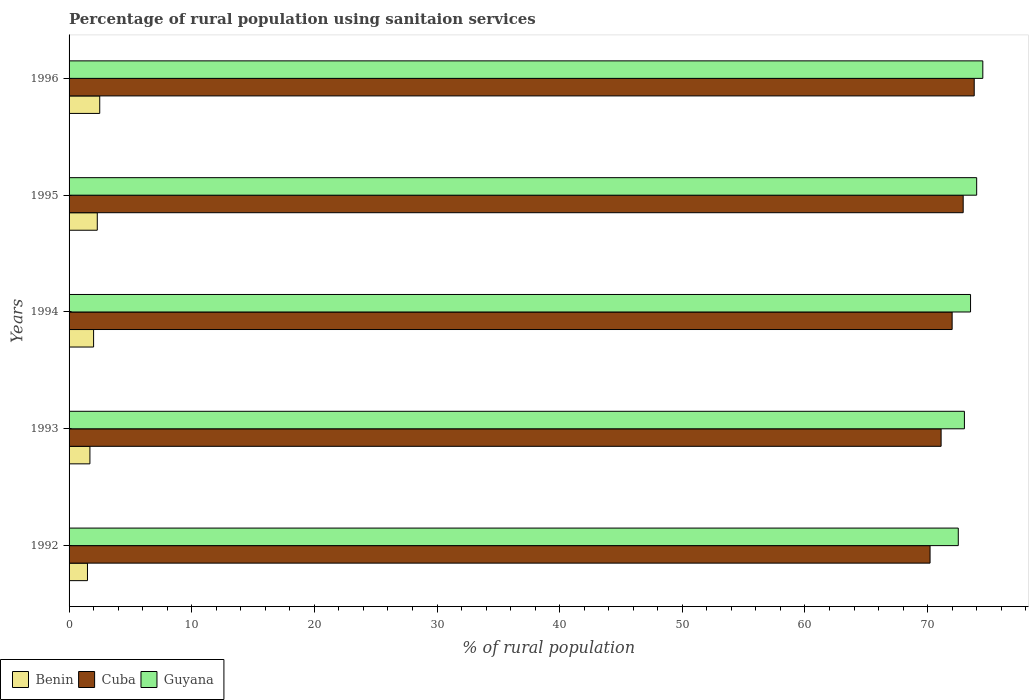How many different coloured bars are there?
Your answer should be compact. 3. How many groups of bars are there?
Provide a short and direct response. 5. Are the number of bars on each tick of the Y-axis equal?
Keep it short and to the point. Yes. In how many cases, is the number of bars for a given year not equal to the number of legend labels?
Ensure brevity in your answer.  0. Across all years, what is the minimum percentage of rural population using sanitaion services in Benin?
Make the answer very short. 1.5. What is the total percentage of rural population using sanitaion services in Cuba in the graph?
Make the answer very short. 360. What is the difference between the percentage of rural population using sanitaion services in Benin in 1994 and that in 1995?
Provide a succinct answer. -0.3. What is the difference between the percentage of rural population using sanitaion services in Benin in 1993 and the percentage of rural population using sanitaion services in Cuba in 1996?
Provide a short and direct response. -72.1. What is the average percentage of rural population using sanitaion services in Cuba per year?
Your answer should be compact. 72. In the year 1992, what is the difference between the percentage of rural population using sanitaion services in Cuba and percentage of rural population using sanitaion services in Guyana?
Ensure brevity in your answer.  -2.3. What is the ratio of the percentage of rural population using sanitaion services in Benin in 1994 to that in 1996?
Your answer should be compact. 0.8. Is the percentage of rural population using sanitaion services in Guyana in 1992 less than that in 1995?
Provide a succinct answer. Yes. What is the difference between the highest and the second highest percentage of rural population using sanitaion services in Guyana?
Provide a short and direct response. 0.5. What is the difference between the highest and the lowest percentage of rural population using sanitaion services in Benin?
Provide a succinct answer. 1. In how many years, is the percentage of rural population using sanitaion services in Benin greater than the average percentage of rural population using sanitaion services in Benin taken over all years?
Offer a terse response. 2. Is the sum of the percentage of rural population using sanitaion services in Cuba in 1993 and 1994 greater than the maximum percentage of rural population using sanitaion services in Benin across all years?
Make the answer very short. Yes. What does the 2nd bar from the top in 1993 represents?
Provide a short and direct response. Cuba. What does the 1st bar from the bottom in 1994 represents?
Make the answer very short. Benin. How many bars are there?
Your answer should be very brief. 15. Are all the bars in the graph horizontal?
Make the answer very short. Yes. Are the values on the major ticks of X-axis written in scientific E-notation?
Offer a terse response. No. Where does the legend appear in the graph?
Provide a short and direct response. Bottom left. What is the title of the graph?
Your answer should be compact. Percentage of rural population using sanitaion services. What is the label or title of the X-axis?
Provide a short and direct response. % of rural population. What is the label or title of the Y-axis?
Your answer should be very brief. Years. What is the % of rural population of Benin in 1992?
Provide a short and direct response. 1.5. What is the % of rural population in Cuba in 1992?
Your response must be concise. 70.2. What is the % of rural population of Guyana in 1992?
Provide a succinct answer. 72.5. What is the % of rural population of Benin in 1993?
Your answer should be very brief. 1.7. What is the % of rural population of Cuba in 1993?
Give a very brief answer. 71.1. What is the % of rural population of Guyana in 1993?
Give a very brief answer. 73. What is the % of rural population in Cuba in 1994?
Offer a terse response. 72. What is the % of rural population of Guyana in 1994?
Your answer should be compact. 73.5. What is the % of rural population of Cuba in 1995?
Provide a succinct answer. 72.9. What is the % of rural population of Guyana in 1995?
Give a very brief answer. 74. What is the % of rural population of Benin in 1996?
Offer a very short reply. 2.5. What is the % of rural population of Cuba in 1996?
Offer a terse response. 73.8. What is the % of rural population in Guyana in 1996?
Offer a very short reply. 74.5. Across all years, what is the maximum % of rural population of Benin?
Provide a short and direct response. 2.5. Across all years, what is the maximum % of rural population of Cuba?
Make the answer very short. 73.8. Across all years, what is the maximum % of rural population in Guyana?
Your answer should be very brief. 74.5. Across all years, what is the minimum % of rural population of Benin?
Make the answer very short. 1.5. Across all years, what is the minimum % of rural population of Cuba?
Ensure brevity in your answer.  70.2. Across all years, what is the minimum % of rural population in Guyana?
Offer a terse response. 72.5. What is the total % of rural population in Benin in the graph?
Your answer should be compact. 10. What is the total % of rural population of Cuba in the graph?
Your answer should be compact. 360. What is the total % of rural population in Guyana in the graph?
Offer a very short reply. 367.5. What is the difference between the % of rural population of Guyana in 1992 and that in 1993?
Offer a very short reply. -0.5. What is the difference between the % of rural population of Guyana in 1992 and that in 1994?
Your answer should be compact. -1. What is the difference between the % of rural population in Benin in 1992 and that in 1995?
Your answer should be compact. -0.8. What is the difference between the % of rural population of Guyana in 1992 and that in 1995?
Keep it short and to the point. -1.5. What is the difference between the % of rural population in Guyana in 1992 and that in 1996?
Your answer should be very brief. -2. What is the difference between the % of rural population in Cuba in 1993 and that in 1994?
Ensure brevity in your answer.  -0.9. What is the difference between the % of rural population of Guyana in 1993 and that in 1994?
Keep it short and to the point. -0.5. What is the difference between the % of rural population in Benin in 1993 and that in 1996?
Give a very brief answer. -0.8. What is the difference between the % of rural population in Cuba in 1993 and that in 1996?
Provide a succinct answer. -2.7. What is the difference between the % of rural population in Benin in 1994 and that in 1995?
Keep it short and to the point. -0.3. What is the difference between the % of rural population in Guyana in 1994 and that in 1995?
Make the answer very short. -0.5. What is the difference between the % of rural population in Benin in 1995 and that in 1996?
Keep it short and to the point. -0.2. What is the difference between the % of rural population in Benin in 1992 and the % of rural population in Cuba in 1993?
Provide a short and direct response. -69.6. What is the difference between the % of rural population of Benin in 1992 and the % of rural population of Guyana in 1993?
Your answer should be compact. -71.5. What is the difference between the % of rural population of Cuba in 1992 and the % of rural population of Guyana in 1993?
Offer a terse response. -2.8. What is the difference between the % of rural population in Benin in 1992 and the % of rural population in Cuba in 1994?
Offer a terse response. -70.5. What is the difference between the % of rural population of Benin in 1992 and the % of rural population of Guyana in 1994?
Provide a short and direct response. -72. What is the difference between the % of rural population of Cuba in 1992 and the % of rural population of Guyana in 1994?
Ensure brevity in your answer.  -3.3. What is the difference between the % of rural population of Benin in 1992 and the % of rural population of Cuba in 1995?
Ensure brevity in your answer.  -71.4. What is the difference between the % of rural population in Benin in 1992 and the % of rural population in Guyana in 1995?
Give a very brief answer. -72.5. What is the difference between the % of rural population of Cuba in 1992 and the % of rural population of Guyana in 1995?
Offer a very short reply. -3.8. What is the difference between the % of rural population in Benin in 1992 and the % of rural population in Cuba in 1996?
Ensure brevity in your answer.  -72.3. What is the difference between the % of rural population in Benin in 1992 and the % of rural population in Guyana in 1996?
Provide a succinct answer. -73. What is the difference between the % of rural population of Cuba in 1992 and the % of rural population of Guyana in 1996?
Your answer should be very brief. -4.3. What is the difference between the % of rural population in Benin in 1993 and the % of rural population in Cuba in 1994?
Your answer should be compact. -70.3. What is the difference between the % of rural population of Benin in 1993 and the % of rural population of Guyana in 1994?
Keep it short and to the point. -71.8. What is the difference between the % of rural population in Benin in 1993 and the % of rural population in Cuba in 1995?
Make the answer very short. -71.2. What is the difference between the % of rural population in Benin in 1993 and the % of rural population in Guyana in 1995?
Provide a succinct answer. -72.3. What is the difference between the % of rural population in Benin in 1993 and the % of rural population in Cuba in 1996?
Provide a succinct answer. -72.1. What is the difference between the % of rural population of Benin in 1993 and the % of rural population of Guyana in 1996?
Provide a short and direct response. -72.8. What is the difference between the % of rural population in Benin in 1994 and the % of rural population in Cuba in 1995?
Keep it short and to the point. -70.9. What is the difference between the % of rural population in Benin in 1994 and the % of rural population in Guyana in 1995?
Make the answer very short. -72. What is the difference between the % of rural population of Cuba in 1994 and the % of rural population of Guyana in 1995?
Your answer should be very brief. -2. What is the difference between the % of rural population in Benin in 1994 and the % of rural population in Cuba in 1996?
Your answer should be compact. -71.8. What is the difference between the % of rural population in Benin in 1994 and the % of rural population in Guyana in 1996?
Ensure brevity in your answer.  -72.5. What is the difference between the % of rural population in Benin in 1995 and the % of rural population in Cuba in 1996?
Your response must be concise. -71.5. What is the difference between the % of rural population of Benin in 1995 and the % of rural population of Guyana in 1996?
Your response must be concise. -72.2. What is the difference between the % of rural population in Cuba in 1995 and the % of rural population in Guyana in 1996?
Keep it short and to the point. -1.6. What is the average % of rural population of Cuba per year?
Provide a succinct answer. 72. What is the average % of rural population in Guyana per year?
Give a very brief answer. 73.5. In the year 1992, what is the difference between the % of rural population of Benin and % of rural population of Cuba?
Provide a succinct answer. -68.7. In the year 1992, what is the difference between the % of rural population in Benin and % of rural population in Guyana?
Give a very brief answer. -71. In the year 1992, what is the difference between the % of rural population of Cuba and % of rural population of Guyana?
Provide a short and direct response. -2.3. In the year 1993, what is the difference between the % of rural population in Benin and % of rural population in Cuba?
Your answer should be very brief. -69.4. In the year 1993, what is the difference between the % of rural population of Benin and % of rural population of Guyana?
Offer a terse response. -71.3. In the year 1994, what is the difference between the % of rural population of Benin and % of rural population of Cuba?
Keep it short and to the point. -70. In the year 1994, what is the difference between the % of rural population of Benin and % of rural population of Guyana?
Your answer should be very brief. -71.5. In the year 1995, what is the difference between the % of rural population of Benin and % of rural population of Cuba?
Provide a short and direct response. -70.6. In the year 1995, what is the difference between the % of rural population in Benin and % of rural population in Guyana?
Offer a very short reply. -71.7. In the year 1996, what is the difference between the % of rural population in Benin and % of rural population in Cuba?
Provide a succinct answer. -71.3. In the year 1996, what is the difference between the % of rural population in Benin and % of rural population in Guyana?
Your answer should be compact. -72. What is the ratio of the % of rural population of Benin in 1992 to that in 1993?
Your response must be concise. 0.88. What is the ratio of the % of rural population of Cuba in 1992 to that in 1993?
Ensure brevity in your answer.  0.99. What is the ratio of the % of rural population in Benin in 1992 to that in 1994?
Offer a very short reply. 0.75. What is the ratio of the % of rural population in Cuba in 1992 to that in 1994?
Your response must be concise. 0.97. What is the ratio of the % of rural population of Guyana in 1992 to that in 1994?
Ensure brevity in your answer.  0.99. What is the ratio of the % of rural population of Benin in 1992 to that in 1995?
Your response must be concise. 0.65. What is the ratio of the % of rural population in Cuba in 1992 to that in 1995?
Ensure brevity in your answer.  0.96. What is the ratio of the % of rural population of Guyana in 1992 to that in 1995?
Your response must be concise. 0.98. What is the ratio of the % of rural population in Benin in 1992 to that in 1996?
Your response must be concise. 0.6. What is the ratio of the % of rural population of Cuba in 1992 to that in 1996?
Offer a terse response. 0.95. What is the ratio of the % of rural population in Guyana in 1992 to that in 1996?
Make the answer very short. 0.97. What is the ratio of the % of rural population of Cuba in 1993 to that in 1994?
Provide a short and direct response. 0.99. What is the ratio of the % of rural population in Guyana in 1993 to that in 1994?
Your answer should be very brief. 0.99. What is the ratio of the % of rural population of Benin in 1993 to that in 1995?
Your answer should be very brief. 0.74. What is the ratio of the % of rural population of Cuba in 1993 to that in 1995?
Offer a terse response. 0.98. What is the ratio of the % of rural population in Guyana in 1993 to that in 1995?
Ensure brevity in your answer.  0.99. What is the ratio of the % of rural population of Benin in 1993 to that in 1996?
Keep it short and to the point. 0.68. What is the ratio of the % of rural population of Cuba in 1993 to that in 1996?
Your answer should be very brief. 0.96. What is the ratio of the % of rural population of Guyana in 1993 to that in 1996?
Ensure brevity in your answer.  0.98. What is the ratio of the % of rural population of Benin in 1994 to that in 1995?
Keep it short and to the point. 0.87. What is the ratio of the % of rural population in Benin in 1994 to that in 1996?
Offer a very short reply. 0.8. What is the ratio of the % of rural population of Cuba in 1994 to that in 1996?
Give a very brief answer. 0.98. What is the ratio of the % of rural population in Guyana in 1994 to that in 1996?
Your answer should be compact. 0.99. What is the ratio of the % of rural population of Cuba in 1995 to that in 1996?
Your answer should be compact. 0.99. What is the difference between the highest and the second highest % of rural population in Benin?
Your response must be concise. 0.2. What is the difference between the highest and the second highest % of rural population of Cuba?
Make the answer very short. 0.9. 